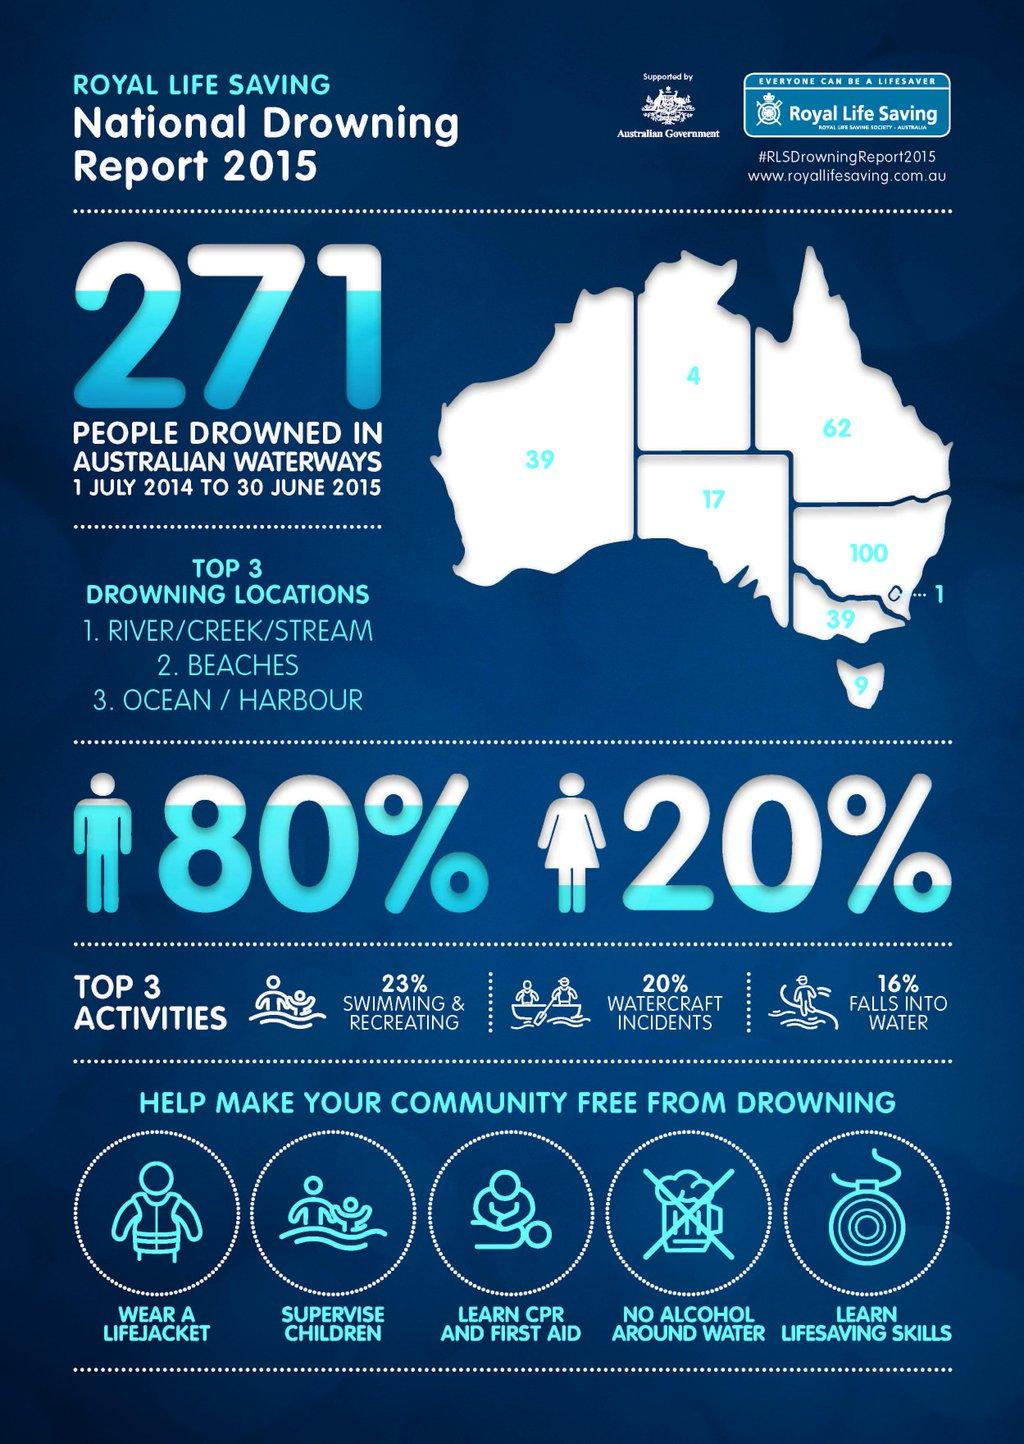Give some essential details in this illustration. One should avoid consuming alcohol while in water to prevent drowning deaths. The percentage difference in deaths between males and females due to drowning is 60%. Watercraft incidents are the second leading cause of death due to drowning. In Western Australia, there were 39 reported deaths due to drowning in the year 2021. New South Wales has the highest number of deaths among the Australian regions. 